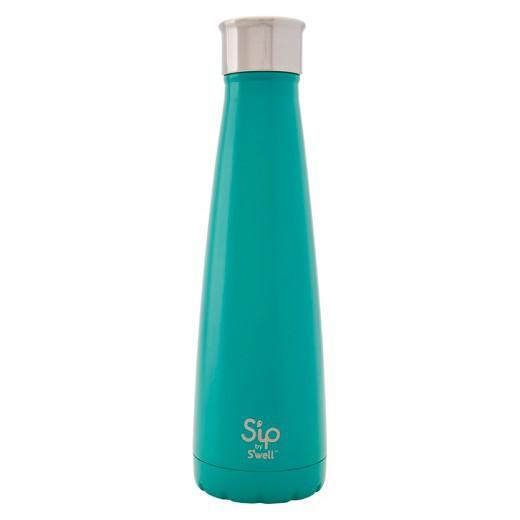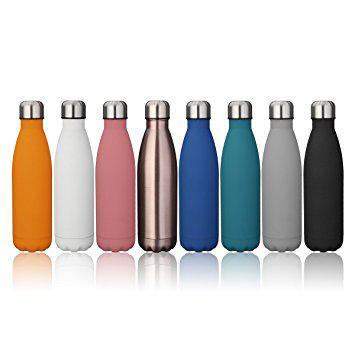The first image is the image on the left, the second image is the image on the right. Assess this claim about the two images: "The left hand image contains a solo water bottle, while the left hand image contains a row or varying colored water bottles.". Correct or not? Answer yes or no. Yes. The first image is the image on the left, the second image is the image on the right. Examine the images to the left and right. Is the description "The bottle in the left image that is closest to the left edge is chrome." accurate? Answer yes or no. No. 